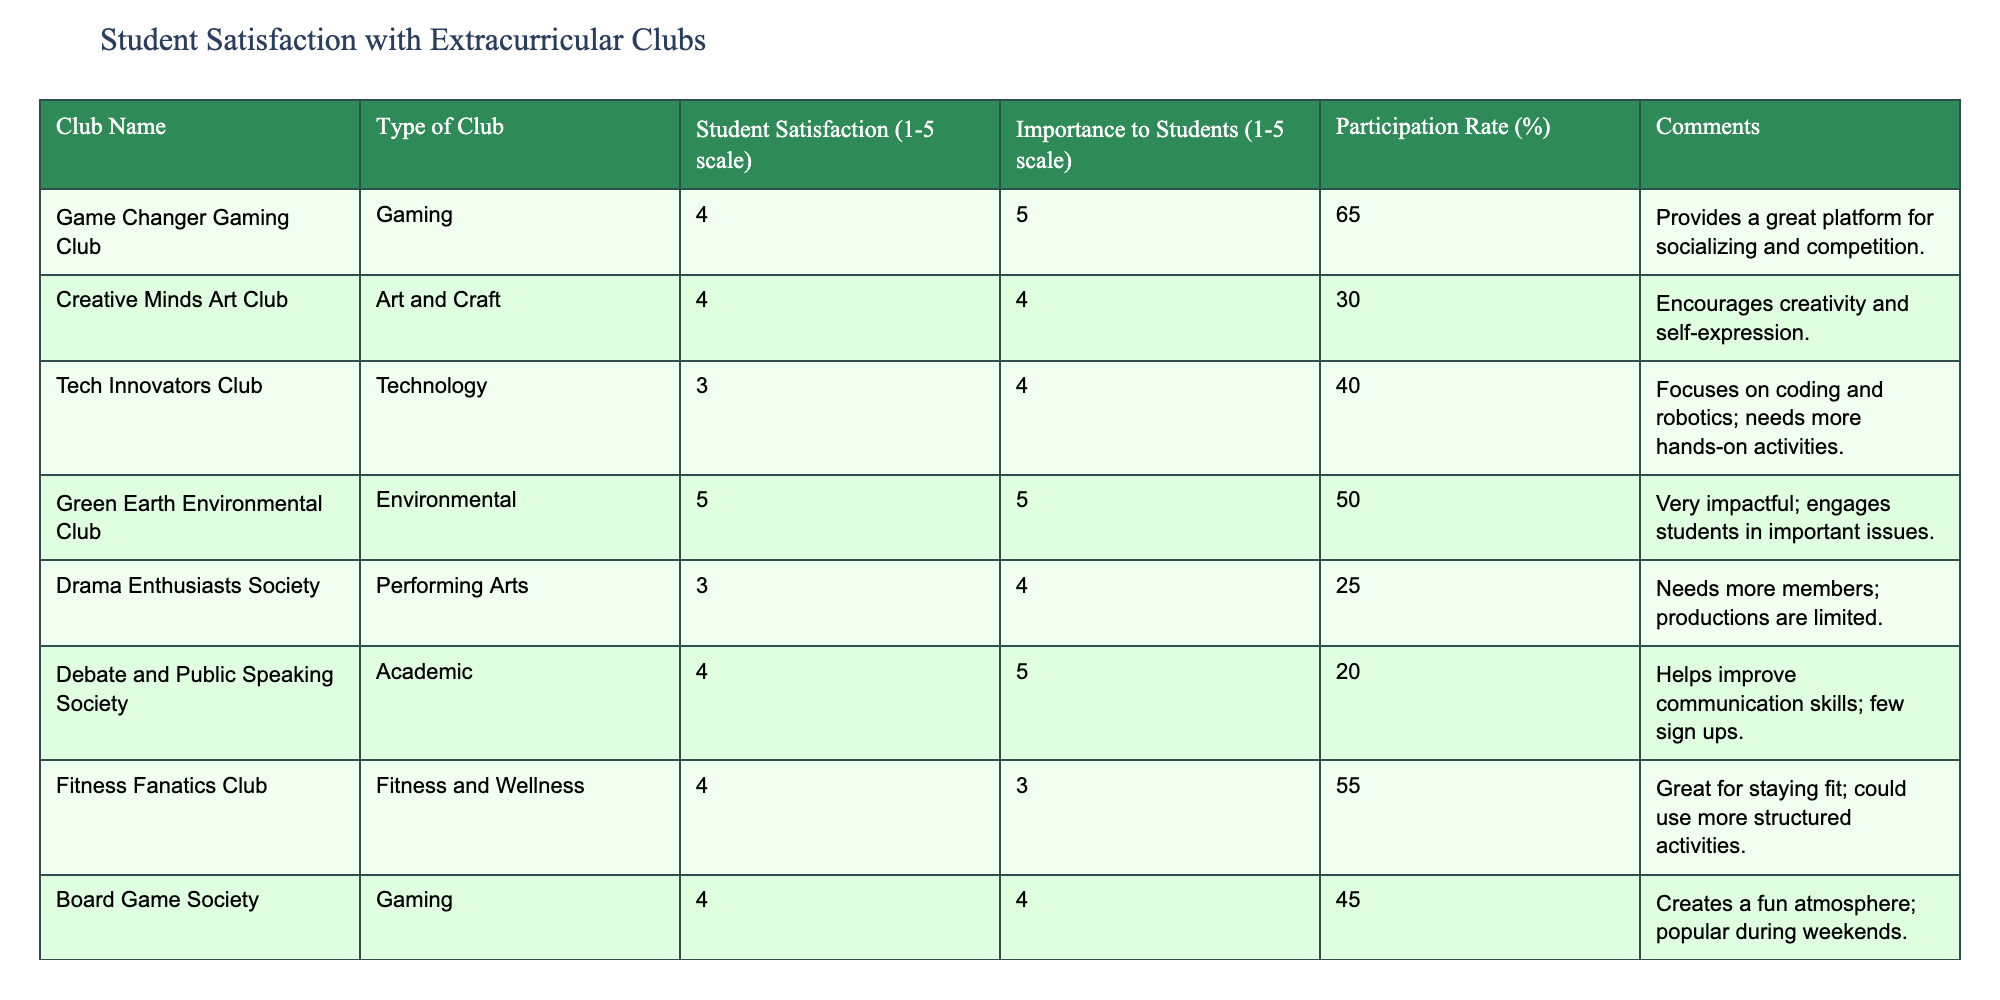What is the student satisfaction rating for the Game Changer Gaming Club? According to the table, the student satisfaction rating for the Game Changer Gaming Club is listed as 4.
Answer: 4 Which club has the highest importance rating according to students? The Green Earth Environmental Club has the highest importance rating of 5, as shown in the Importance to Students column.
Answer: Green Earth Environmental Club What is the average participation rate of all the clubs listed in the table? To find the average participation rate, we add all the participation rates: (65 + 30 + 40 + 50 + 25 + 20 + 55 + 45 + 35) = 365. There are 9 clubs, so the average is 365/9 ≈ 40.56.
Answer: Approximately 40.56 Is the Tech Innovators Club rated higher in satisfaction than the Board Game Society? The Tech Innovators Club has a satisfaction rating of 3, while the Board Game Society has a rating of 4. Since 3 is less than 4, Tech Innovators is not rated higher.
Answer: No Which type of club has the lowest participation rate, and what is that percentage? Looking at the Participation Rate column, the Debate and Public Speaking Society has the lowest participation rate at 20%.
Answer: Debate and Public Speaking Society, 20% What is the difference in student satisfaction ratings between the Science Explorers Club and the Drama Enthusiasts Society? The Science Explorers Club has a satisfaction rating of 5, while the Drama Enthusiasts Society has a rating of 3. The difference is 5 - 3 = 2.
Answer: 2 Are there any clubs that have a student satisfaction rating of 5? Yes, both the Green Earth Environmental Club and the Science Explorers Club have a student satisfaction rating of 5.
Answer: Yes Which gaming club has a higher importance rating, the Game Changer Gaming Club or the Board Game Society? The Game Changer Gaming Club has an importance rating of 5, whereas the Board Game Society has a rating of 4. Since 5 is greater than 4, Game Changer has a higher importance rating.
Answer: Game Changer Gaming Club 